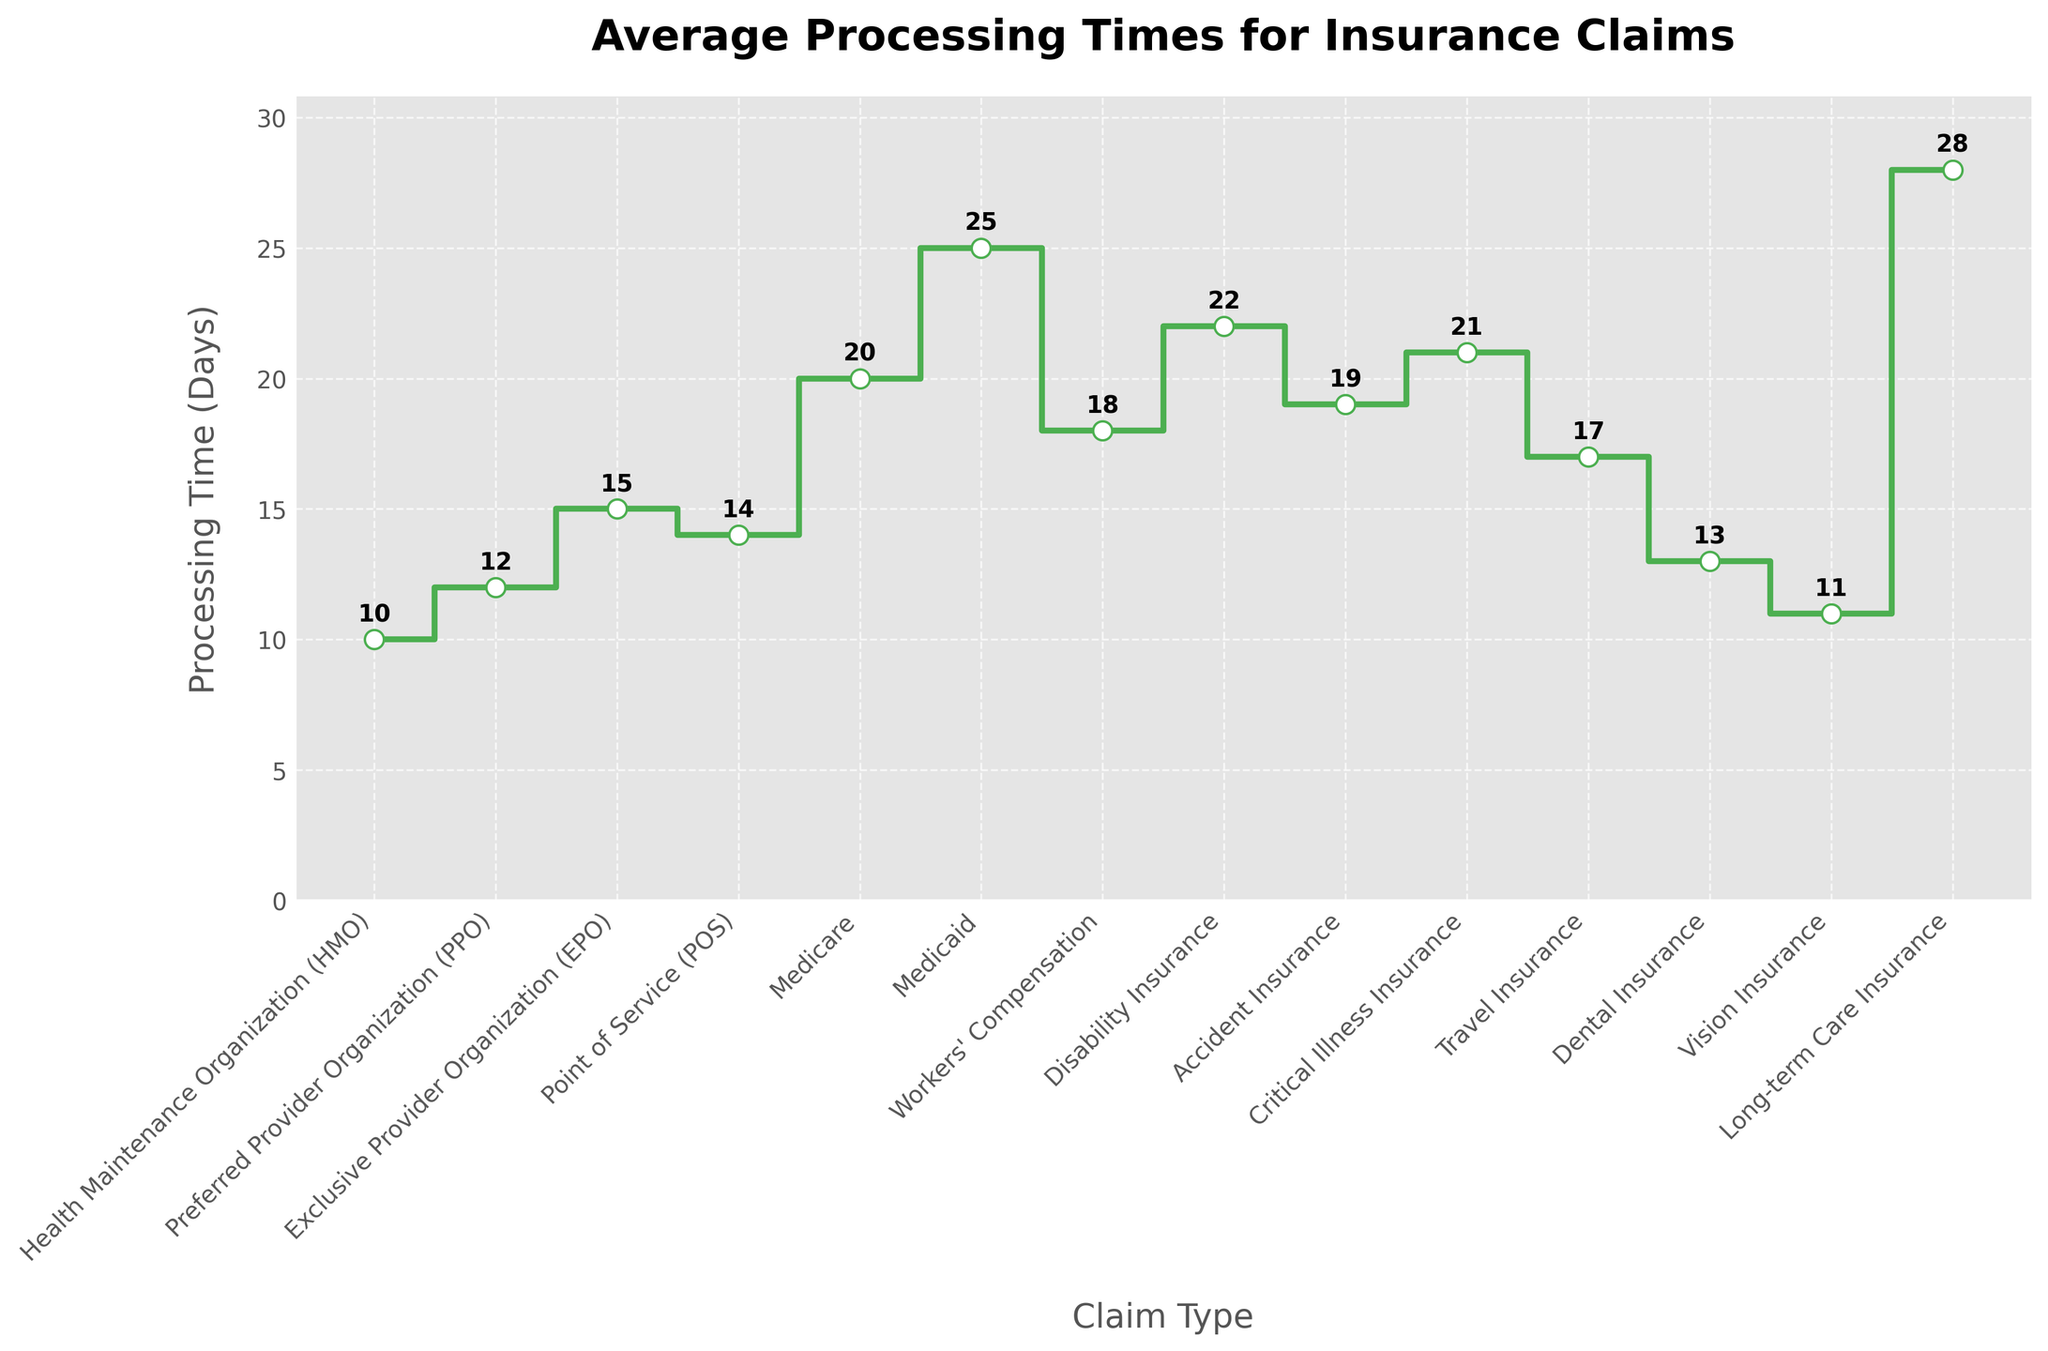What is the title of the plot? Read the text at the top of the figure which states the purpose of the plot.
Answer: Average Processing Times for Insurance Claims How many different claim types are shown in the plot? Count the number of unique data points or markers given on the x-axis.
Answer: 14 Which claim type has the highest average processing time? Identify the claim type with the highest point on the y-axis.
Answer: Long-term Care Insurance What is the average processing time for Vision Insurance? Locate the point associated with Vision Insurance along the x-axis and read the corresponding y-axis value.
Answer: 11 days Compare the average processing times of PPO and Dental Insurance. Which is higher? Find both points for PPO and Dental Insurance on the plot, compare their y-axis values.
Answer: PPO Calculate the difference in average processing time between Medicare and Medicaid. Subtract the processing time of Medicare from Medicaid, which is 25 - 20.
Answer: 5 days What is the average processing time for claims exceeding 20 days? Identify claim times greater than 20 days: Medicaid (25), Disability Insurance (22), Critical Illness Insurance (21), Long-term Care Insurance (28). Compute the average: (25 + 22 + 21 + 28) / 4.
Answer: 24 days Are there any claim types with an average processing time of exactly 20 days? Check the x-axis labels and their corresponding y-axis values for a match with 20 days.
Answer: Medicare What is the range of average processing times shown in the plot? Find the difference between the maximum and minimum processing times, 28 - 10.
Answer: 18 days How does the average processing time for Workers' Compensation compare to Travel Insurance? Look at both data points for Workers' Compensation and Travel Insurance and compare their y-axis values.
Answer: Workers' Compensation is higher 